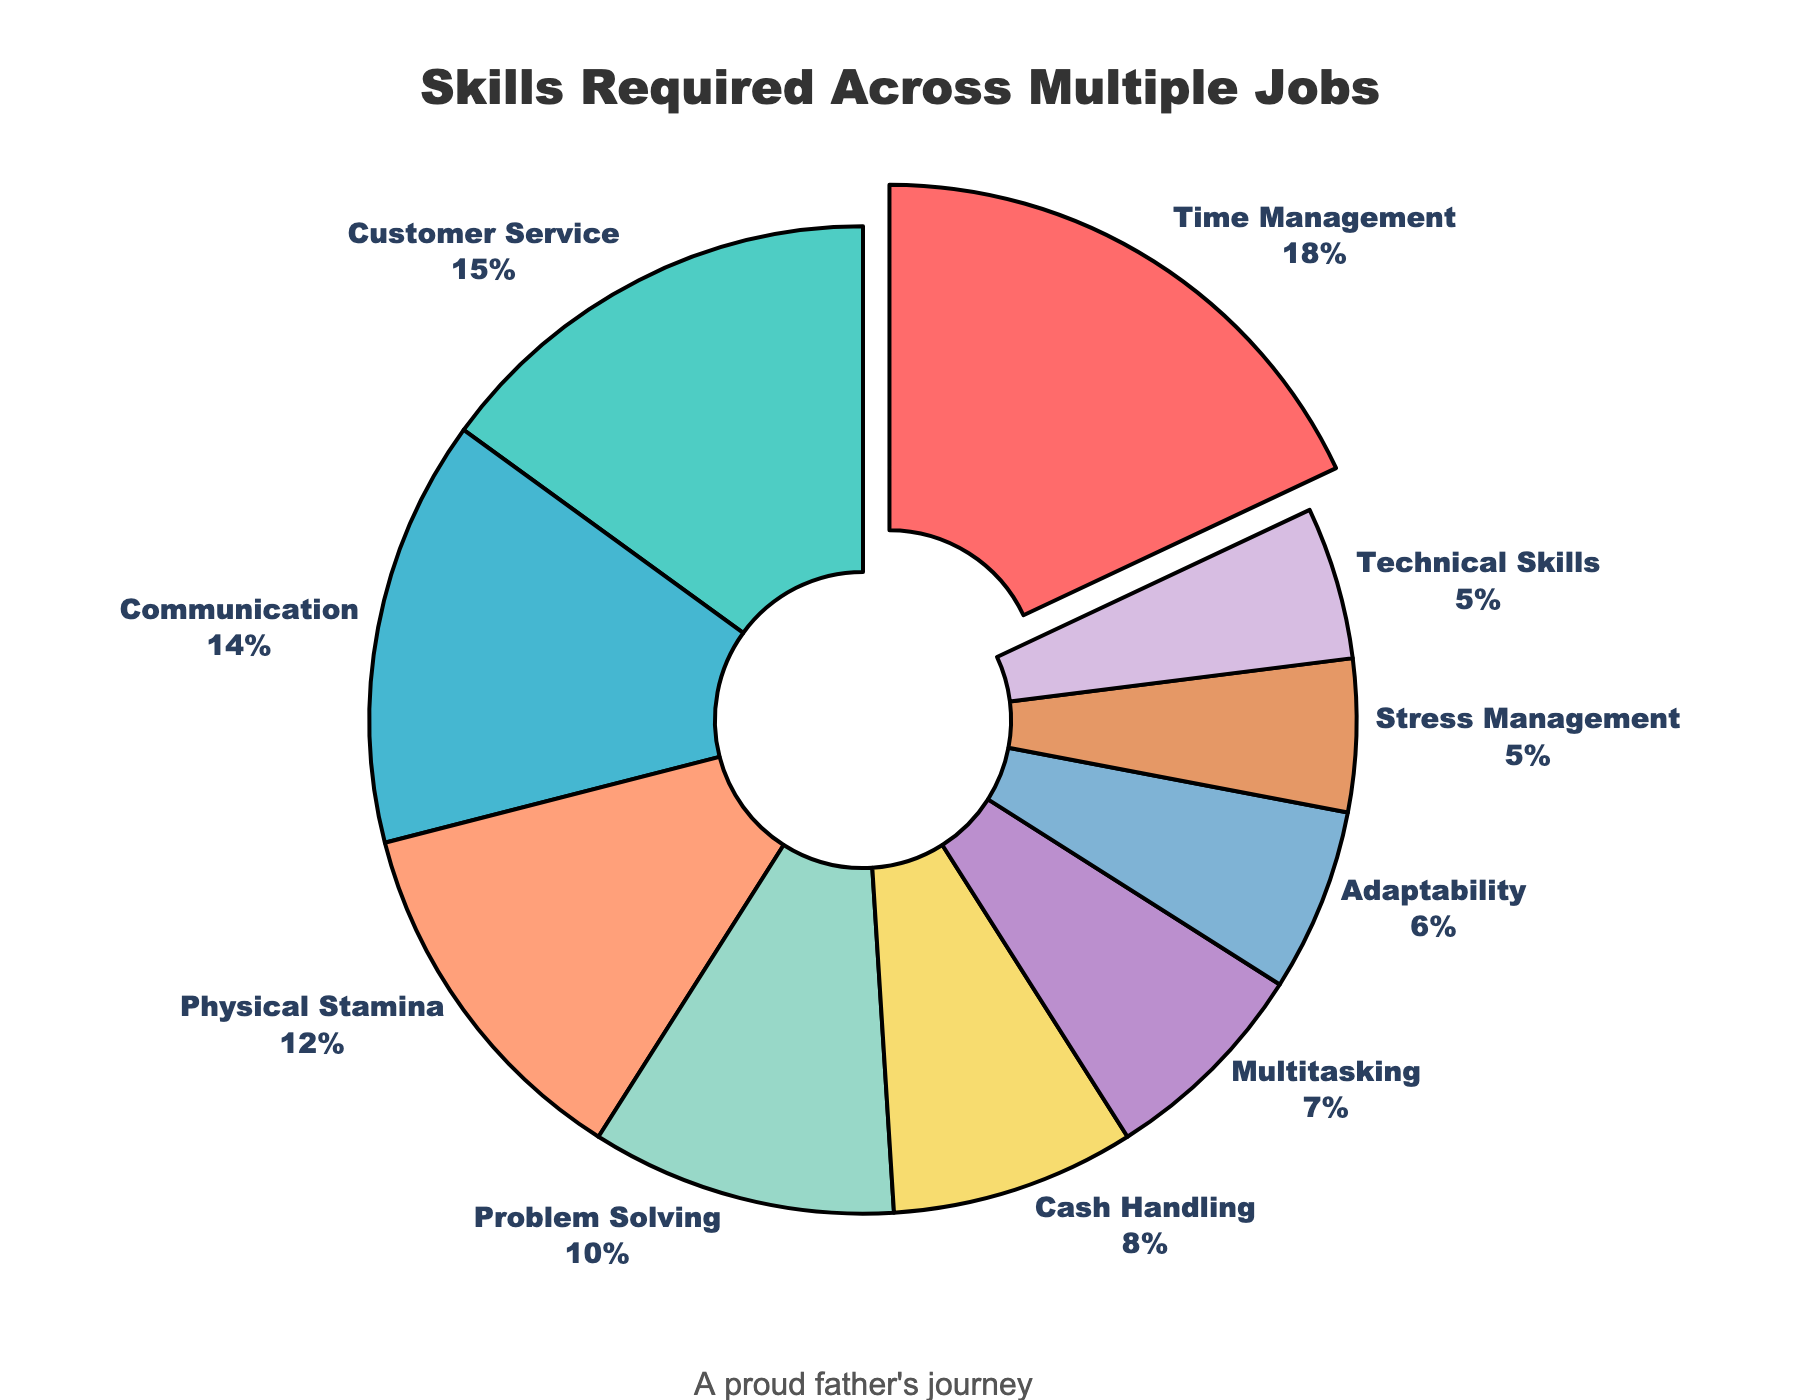What's the proportion of "Time Management" compared to "Adaptability"? "Time Management" is shown with 18% in the figure, and "Adaptability" is 6%. To compare them, divide 18 by 6, which equals 3. So, "Time Management" is 3 times the percentage of "Adaptability".
Answer: 3 times Which skill is highlighted by being slightly pulled out from the pie chart? The "Time Management" section is visually pulled out from the rest of the pie chart, making it stand out.
Answer: Time Management Identify two skills whose combined percentage equals the percentage for "Time Management". "Time Management" is 18%. Adding "Cash Handling" (8%) and "Multitasking" (7%) gives 15%, which is still not enough. Adding another 3% from "Stress Management" (5%) makes it 8 + 7 + 3 = 18%.
Answer: Cash Handling and Multitasking (with part of Stress Management) What percentage of the skills chart is made up of "Technical Skills" and "Adaptability" combined? "Technical Skills" is shown with 5% and "Adaptability" with 6%, so combined, that is 5 + 6 = 11%.
Answer: 11% Which skill is represented by the orange color in the chart? The skill represented by the orange color is "Physical Stamina" with 12%, as visually shown in the chart legend or sections.
Answer: Physical Stamina Calculate the difference in percentages between "Customer Service" and "Problem Solving". "Customer Service" is 15% and "Problem Solving" is 10%. Subtracting 10 from 15 gives 5%.
Answer: 5% Compare the sum of the percentages for "Communication" and "Multitasking" with that of "Time Management". "Communication" is 14% and "Multitasking" is 7%, which sums to 21%. "Time Management" alone is 18%. 21 is 3 more than 18.
Answer: 3% more What is the smallest skill percentage, and which skill does it represent? The smallest skill percentages are "Stress Management" and "Technical Skills", each at 5%, as indicated in the pie chart.
Answer: Stress Management and Technical Skills 